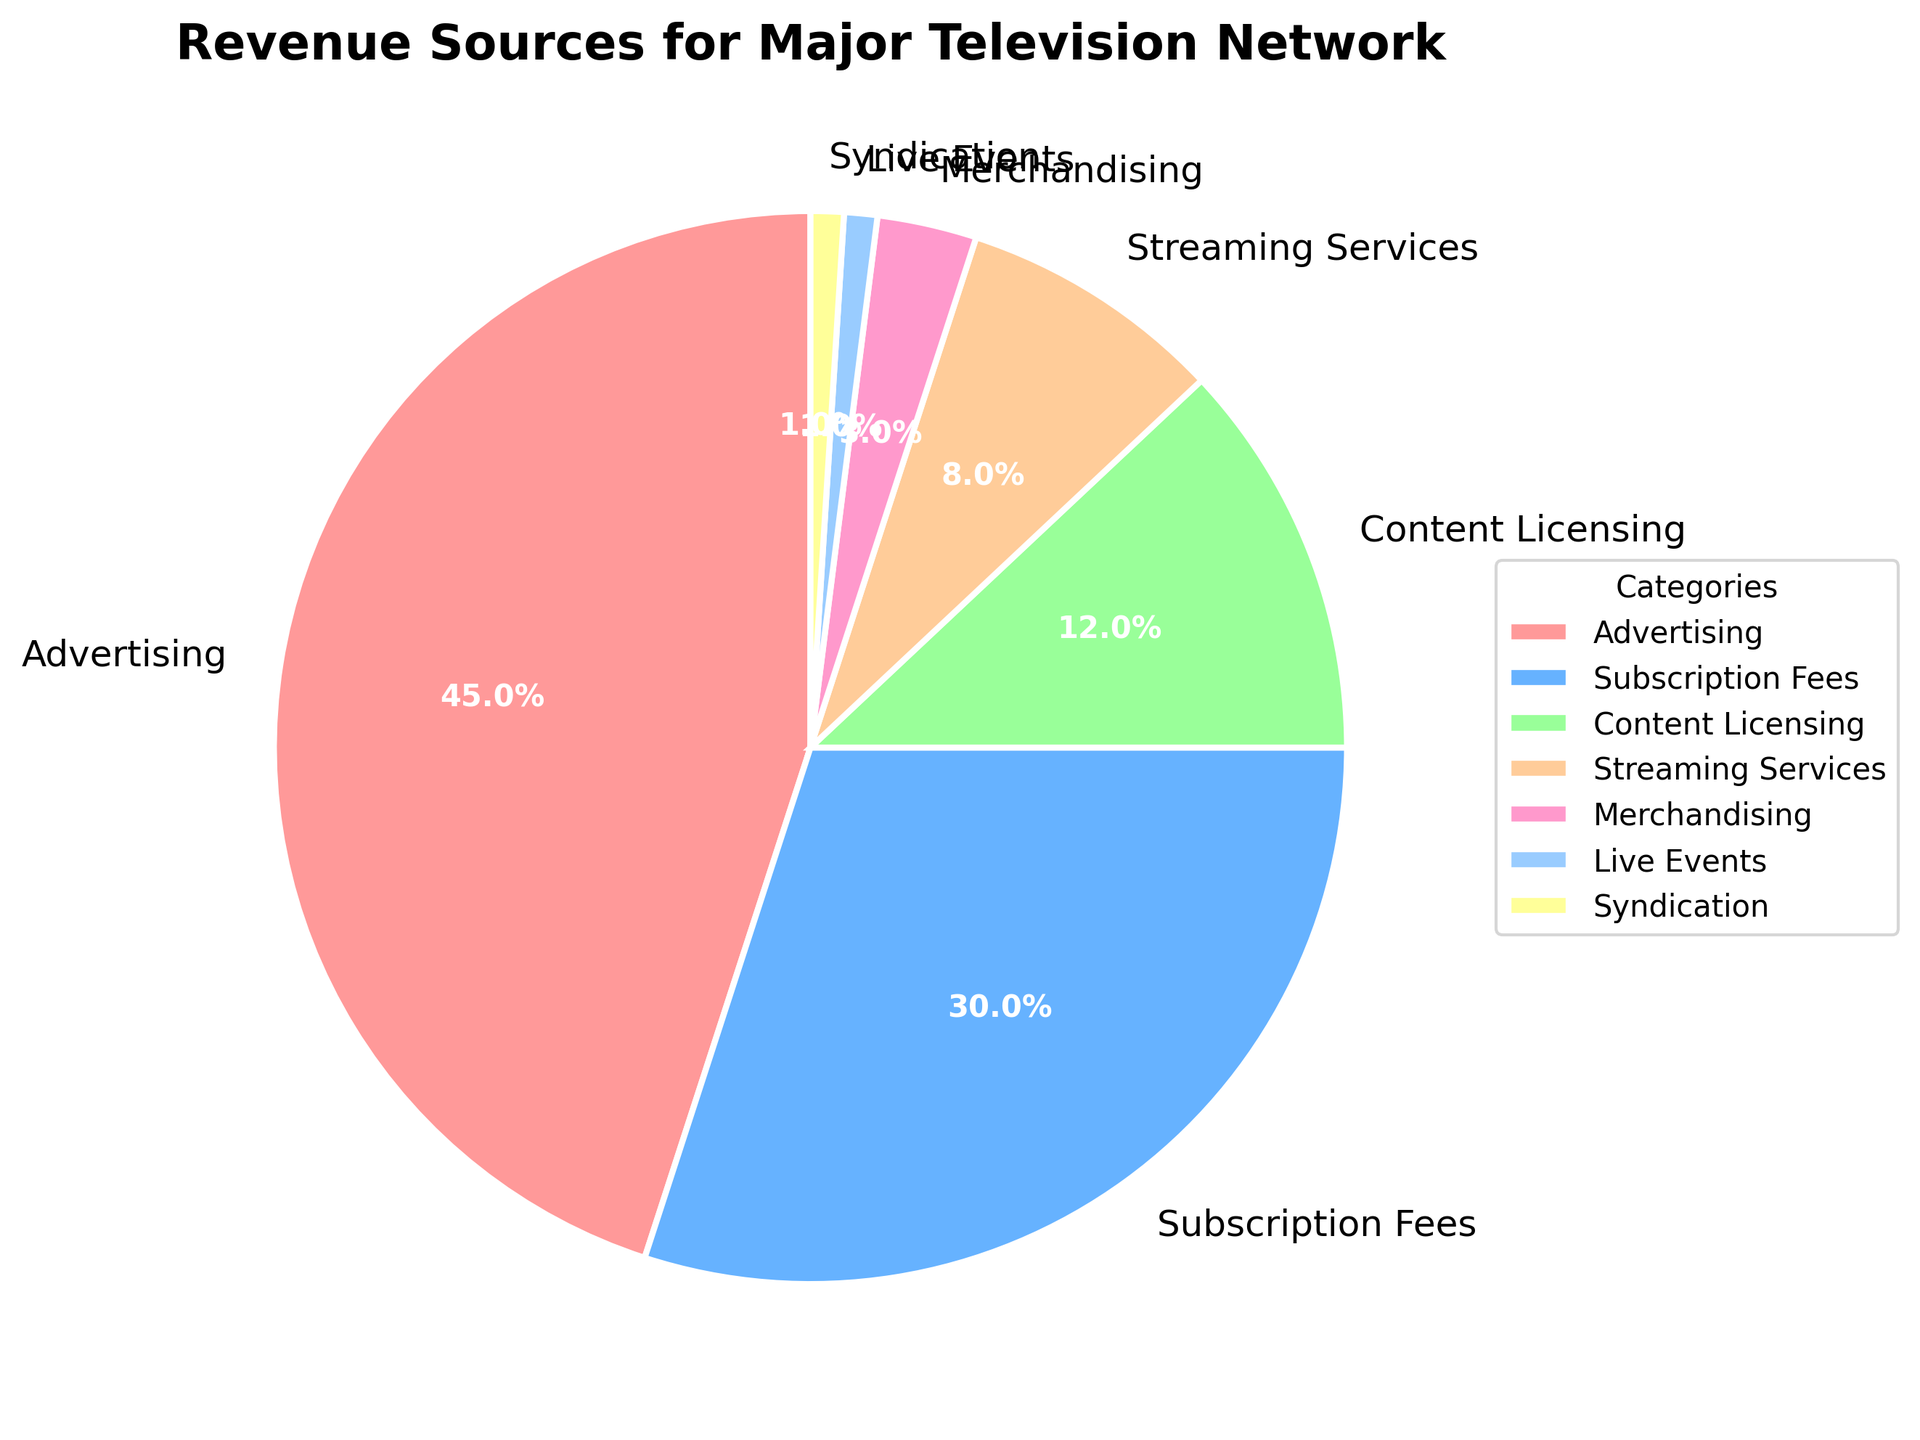What's the largest source of revenue for the television network? The pie chart shows multiple revenue sources with varying percentages. By observing the chart, the slice labeled "Advertising" covers the largest portion at 45%.
Answer: Advertising Which revenue source contributes more: Content Licensing or Streaming Services? To determine which source contributes more, compare their percentages. Content Licensing is at 12% while Streaming Services is at 8%. Hence, Content Licensing contributes more.
Answer: Content Licensing What is the combined percentage of revenue from Merchandising and Live Events? Add the percentages of the two categories: Merchandising (3%) and Live Events (1%). The combined percentage is 3% + 1% = 4%.
Answer: 4% Is the sum of revenue from Syndication and Live Events greater than that from Merchandising? Calculate the sum for Syndication and Live Events: 1% + 1% = 2%. Compare this with Merchandising at 3%. The sum of Syndication and Live Events is not greater than Merchandising.
Answer: No What are the colors of the slices representing the three smallest revenue sources? By observing the pie chart's color coding, the three smallest slices are Live Events, Syndication, and Merchandising. These slices are represented by colors which can be visually identified.
Answer: Check visually for colors of Live Events (smallest), Syndication, and Merchandising How much higher is the percentage of revenue from Subscription Fees compared to Streaming Services? Subtract the percentage of Streaming Services (8%) from that of Subscription Fees (30%): 30% - 8% = 22%.
Answer: 22% What percentage of the total revenue comes from non-advertising sources? Subtract the advertising percentage (45%) from 100% to find the non-advertising percentage: 100% - 45% = 55%.
Answer: 55% Which revenue source has a percentage closest to 10%? By observing the pie chart, Content Licensing has a percentage (12%) closest to 10%.
Answer: Content Licensing 